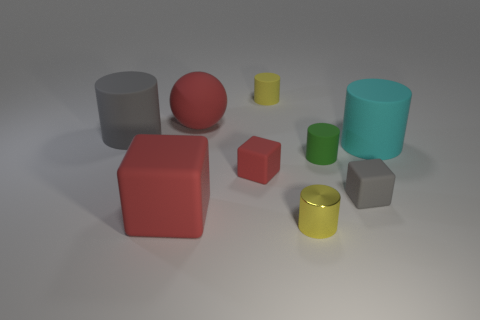Subtract 2 cylinders. How many cylinders are left? 3 Subtract all green cylinders. How many cylinders are left? 4 Subtract all cyan rubber cylinders. How many cylinders are left? 4 Subtract all blue cylinders. Subtract all red spheres. How many cylinders are left? 5 Subtract all cylinders. How many objects are left? 4 Subtract 0 yellow spheres. How many objects are left? 9 Subtract all tiny yellow cylinders. Subtract all large yellow metallic blocks. How many objects are left? 7 Add 3 cyan cylinders. How many cyan cylinders are left? 4 Add 1 small yellow matte cylinders. How many small yellow matte cylinders exist? 2 